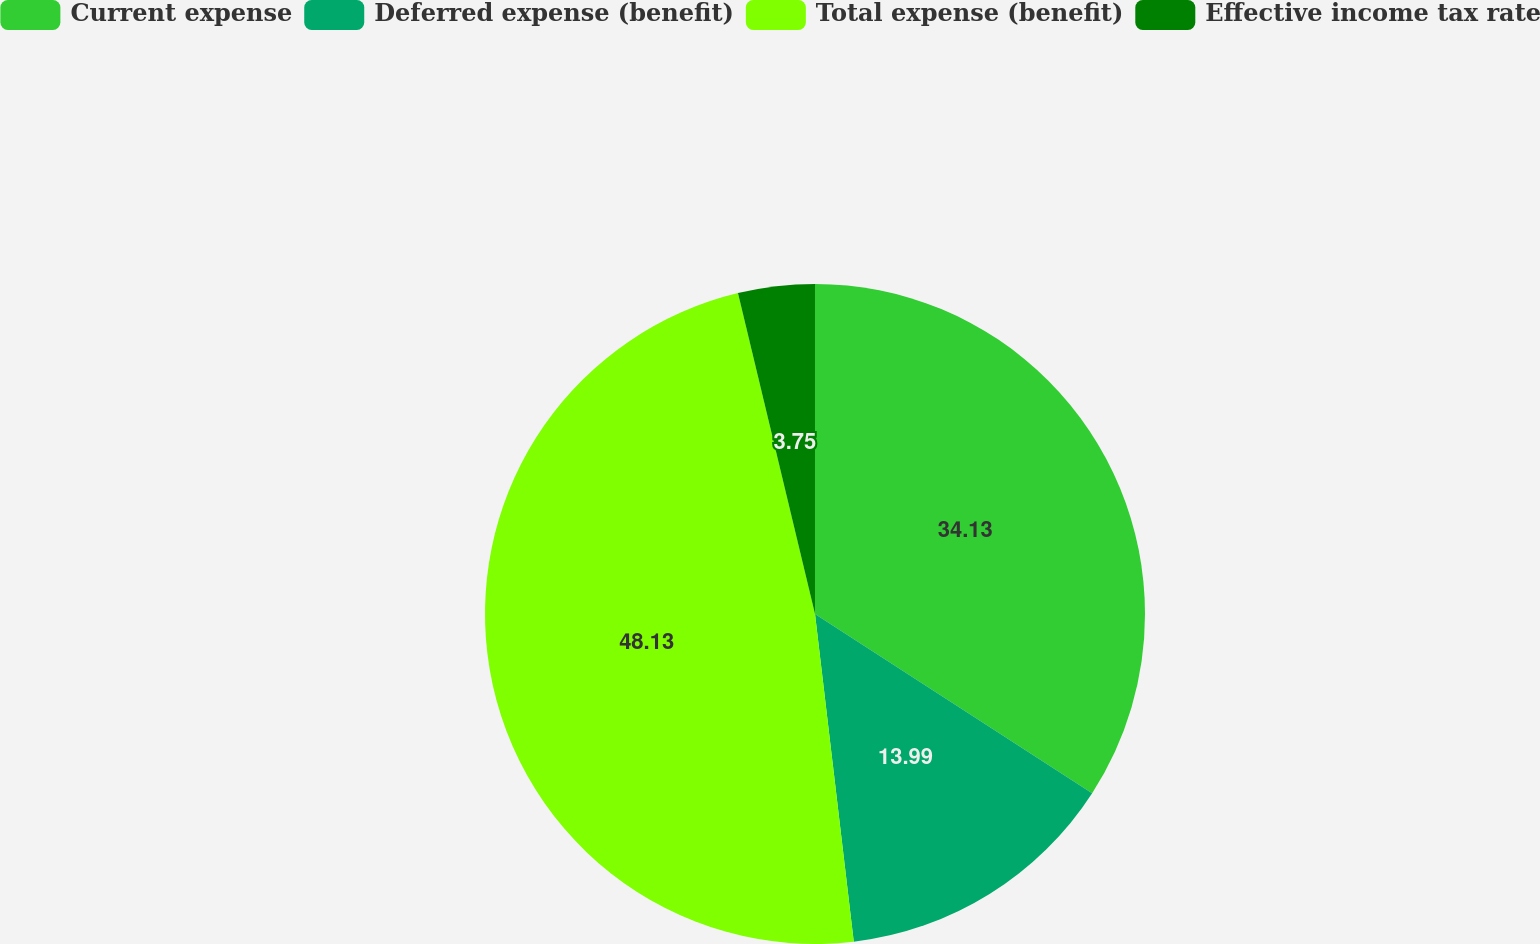<chart> <loc_0><loc_0><loc_500><loc_500><pie_chart><fcel>Current expense<fcel>Deferred expense (benefit)<fcel>Total expense (benefit)<fcel>Effective income tax rate<nl><fcel>34.13%<fcel>13.99%<fcel>48.12%<fcel>3.75%<nl></chart> 